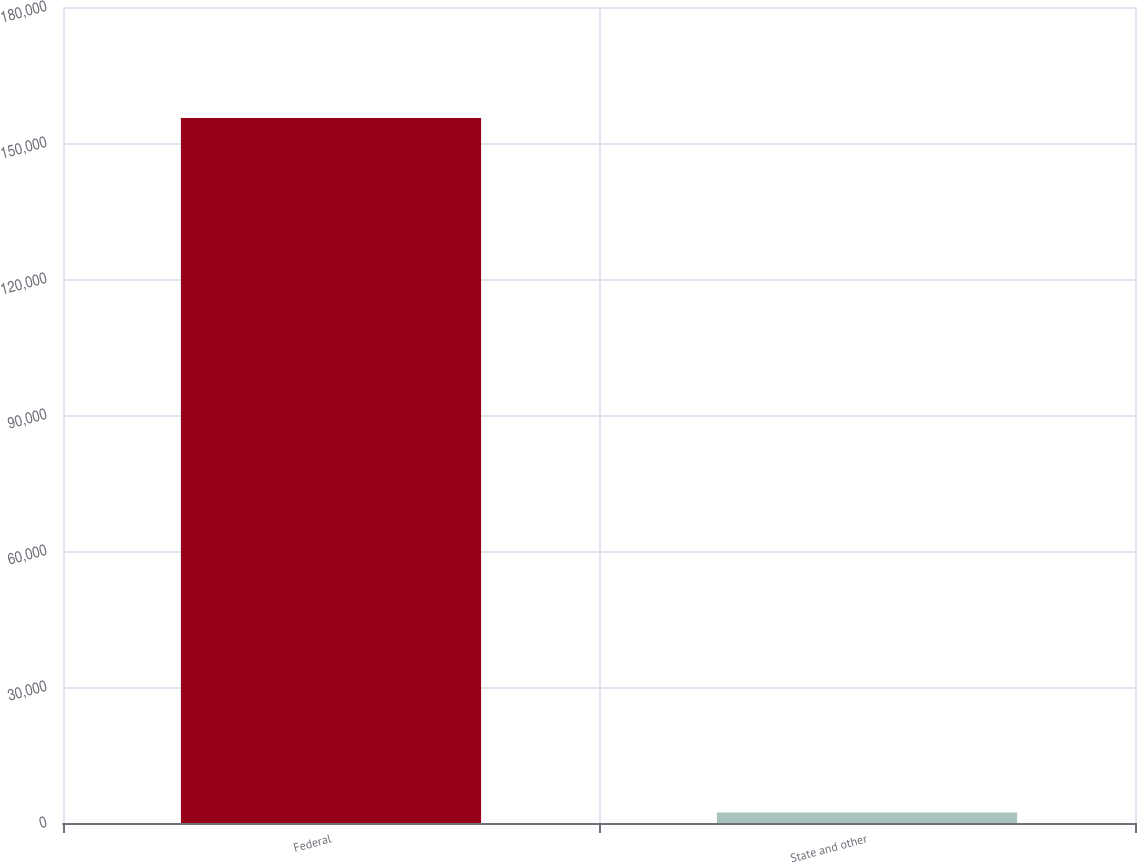Convert chart to OTSL. <chart><loc_0><loc_0><loc_500><loc_500><bar_chart><fcel>Federal<fcel>State and other<nl><fcel>155530<fcel>2302<nl></chart> 